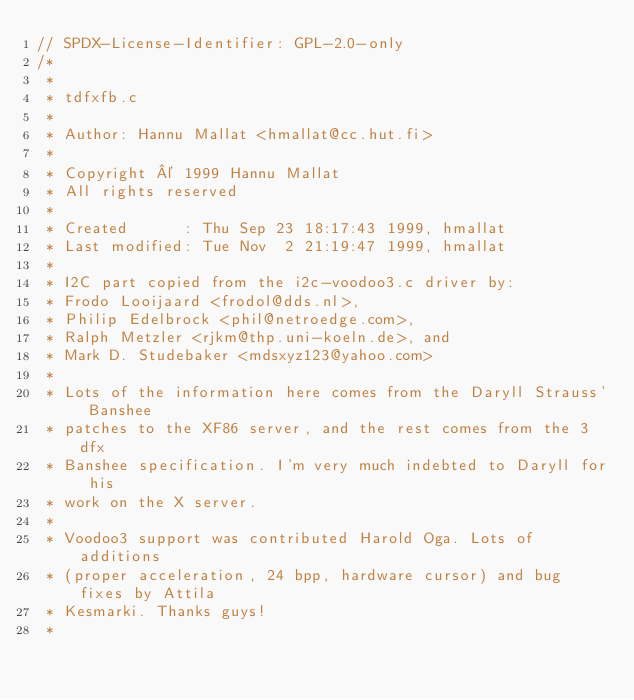Convert code to text. <code><loc_0><loc_0><loc_500><loc_500><_C_>// SPDX-License-Identifier: GPL-2.0-only
/*
 *
 * tdfxfb.c
 *
 * Author: Hannu Mallat <hmallat@cc.hut.fi>
 *
 * Copyright © 1999 Hannu Mallat
 * All rights reserved
 *
 * Created      : Thu Sep 23 18:17:43 1999, hmallat
 * Last modified: Tue Nov  2 21:19:47 1999, hmallat
 *
 * I2C part copied from the i2c-voodoo3.c driver by:
 * Frodo Looijaard <frodol@dds.nl>,
 * Philip Edelbrock <phil@netroedge.com>,
 * Ralph Metzler <rjkm@thp.uni-koeln.de>, and
 * Mark D. Studebaker <mdsxyz123@yahoo.com>
 *
 * Lots of the information here comes from the Daryll Strauss' Banshee
 * patches to the XF86 server, and the rest comes from the 3dfx
 * Banshee specification. I'm very much indebted to Daryll for his
 * work on the X server.
 *
 * Voodoo3 support was contributed Harold Oga. Lots of additions
 * (proper acceleration, 24 bpp, hardware cursor) and bug fixes by Attila
 * Kesmarki. Thanks guys!
 *</code> 